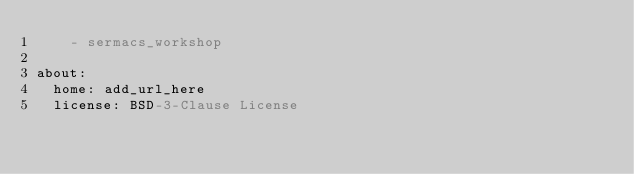<code> <loc_0><loc_0><loc_500><loc_500><_YAML_>    - sermacs_workshop

about:
  home: add_url_here
  license: BSD-3-Clause License
</code> 